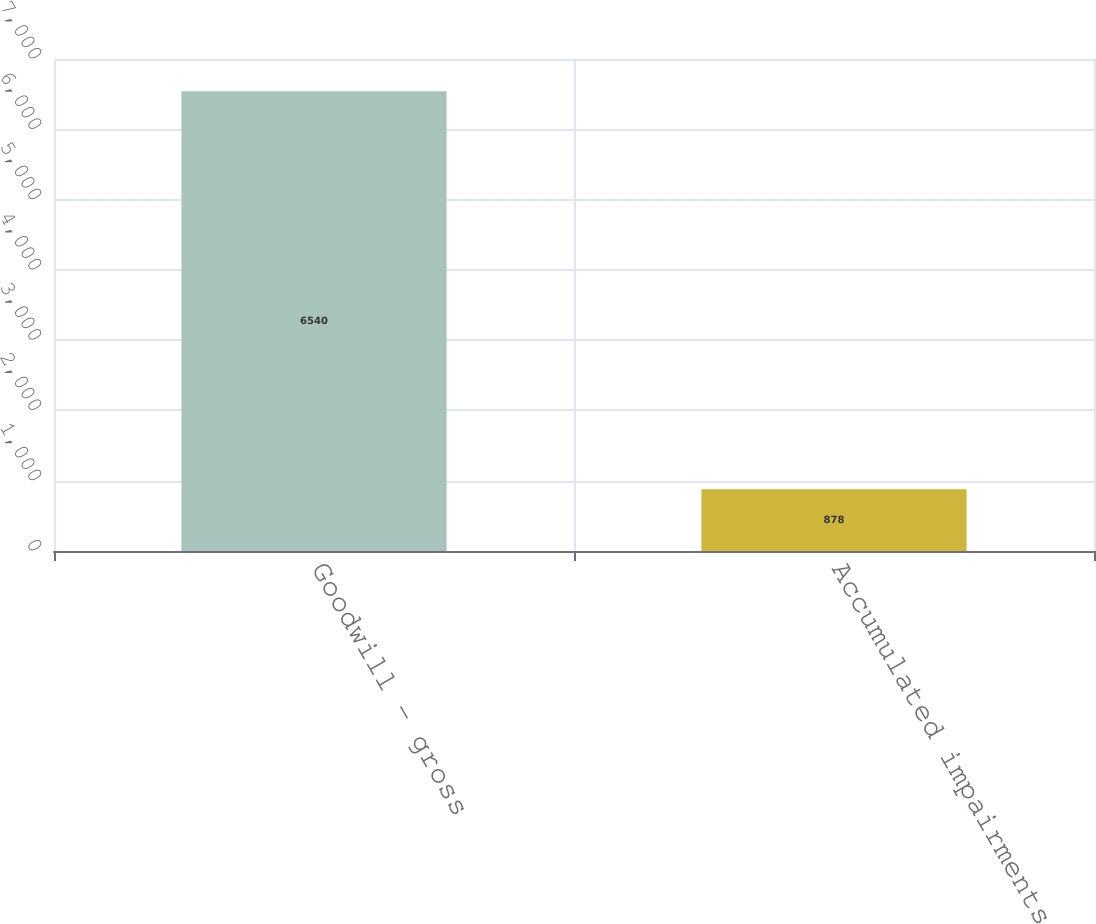Convert chart to OTSL. <chart><loc_0><loc_0><loc_500><loc_500><bar_chart><fcel>Goodwill - gross<fcel>Accumulated impairments<nl><fcel>6540<fcel>878<nl></chart> 